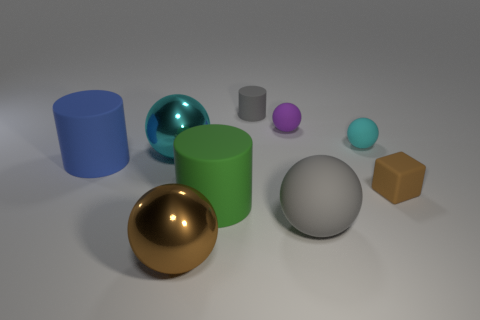There is a matte cylinder that is on the left side of the big cyan shiny ball; how many shiny objects are on the right side of it?
Offer a very short reply. 2. Is there a big metal ball?
Ensure brevity in your answer.  Yes. Is there a gray cylinder that has the same material as the tiny block?
Your response must be concise. Yes. Is the number of brown shiny objects to the right of the big blue thing greater than the number of gray objects that are on the right side of the tiny brown thing?
Offer a terse response. Yes. Do the purple thing and the blue matte cylinder have the same size?
Provide a short and direct response. No. What color is the matte cylinder that is to the left of the big shiny sphere behind the brown matte block?
Give a very brief answer. Blue. The matte block has what color?
Your answer should be compact. Brown. Are there any rubber cylinders that have the same color as the block?
Ensure brevity in your answer.  No. There is a metal sphere behind the small brown object; does it have the same color as the tiny cylinder?
Your answer should be very brief. No. What number of things are either objects in front of the large green rubber cylinder or tiny blue rubber cubes?
Provide a short and direct response. 2. 